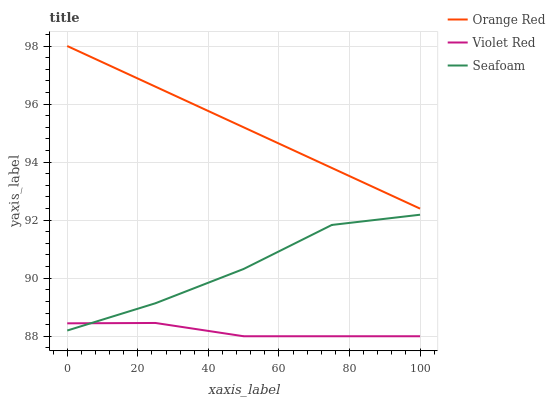Does Seafoam have the minimum area under the curve?
Answer yes or no. No. Does Seafoam have the maximum area under the curve?
Answer yes or no. No. Is Seafoam the smoothest?
Answer yes or no. No. Is Orange Red the roughest?
Answer yes or no. No. Does Seafoam have the lowest value?
Answer yes or no. No. Does Seafoam have the highest value?
Answer yes or no. No. Is Violet Red less than Orange Red?
Answer yes or no. Yes. Is Orange Red greater than Violet Red?
Answer yes or no. Yes. Does Violet Red intersect Orange Red?
Answer yes or no. No. 